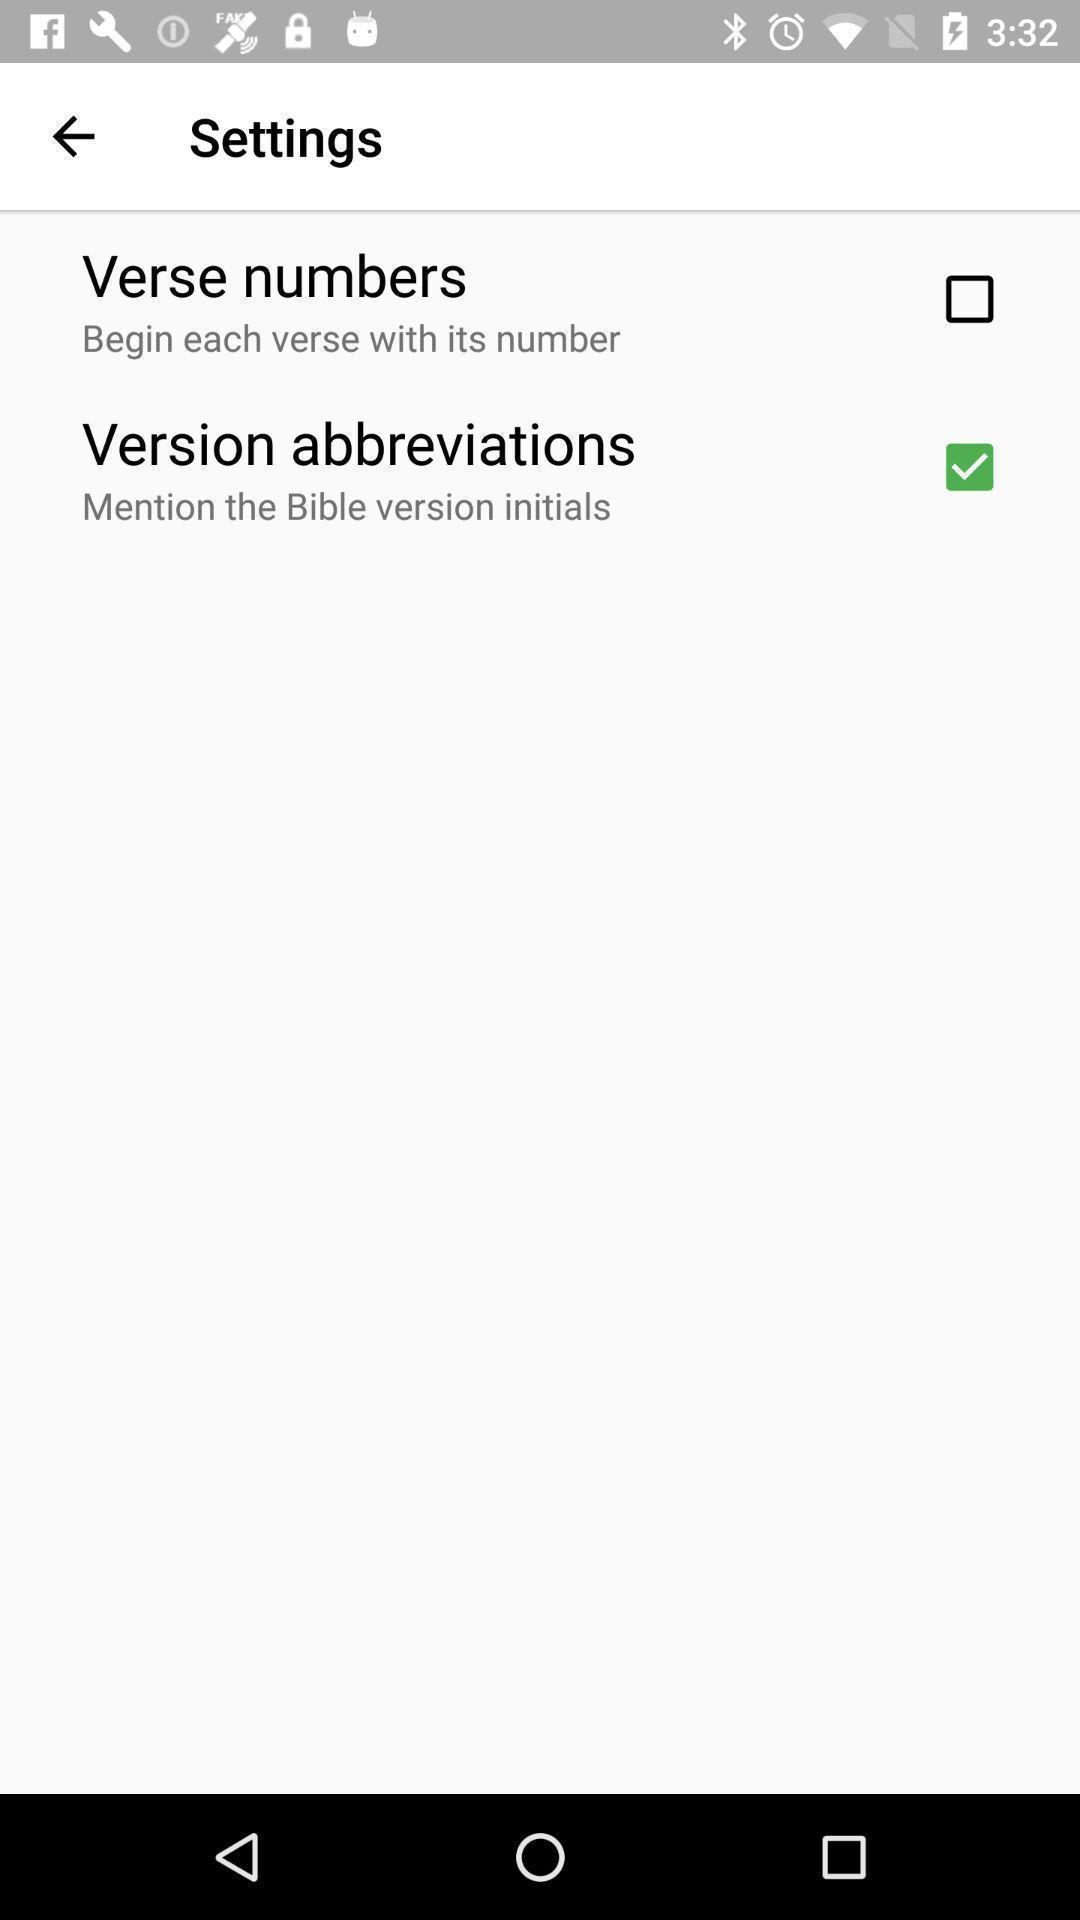Provide a textual representation of this image. Screen displaying list of settings. 